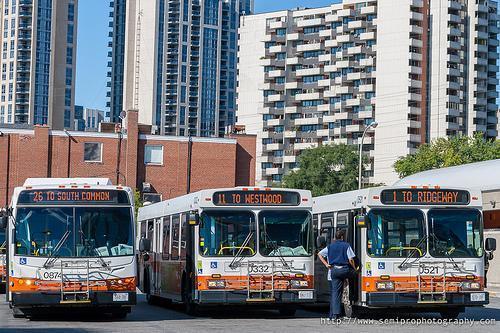How many buses are in the picture?
Give a very brief answer. 3. How many buses are there?
Give a very brief answer. 3. 